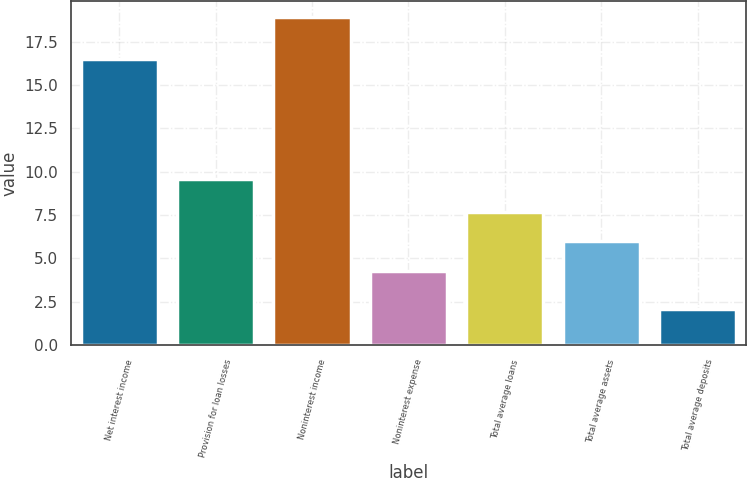Convert chart. <chart><loc_0><loc_0><loc_500><loc_500><bar_chart><fcel>Net interest income<fcel>Provision for loan losses<fcel>Noninterest income<fcel>Noninterest expense<fcel>Total average loans<fcel>Total average assets<fcel>Total average deposits<nl><fcel>16.5<fcel>9.6<fcel>18.9<fcel>4.3<fcel>7.66<fcel>5.98<fcel>2.1<nl></chart> 